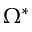Convert formula to latex. <formula><loc_0><loc_0><loc_500><loc_500>\Omega ^ { * }</formula> 